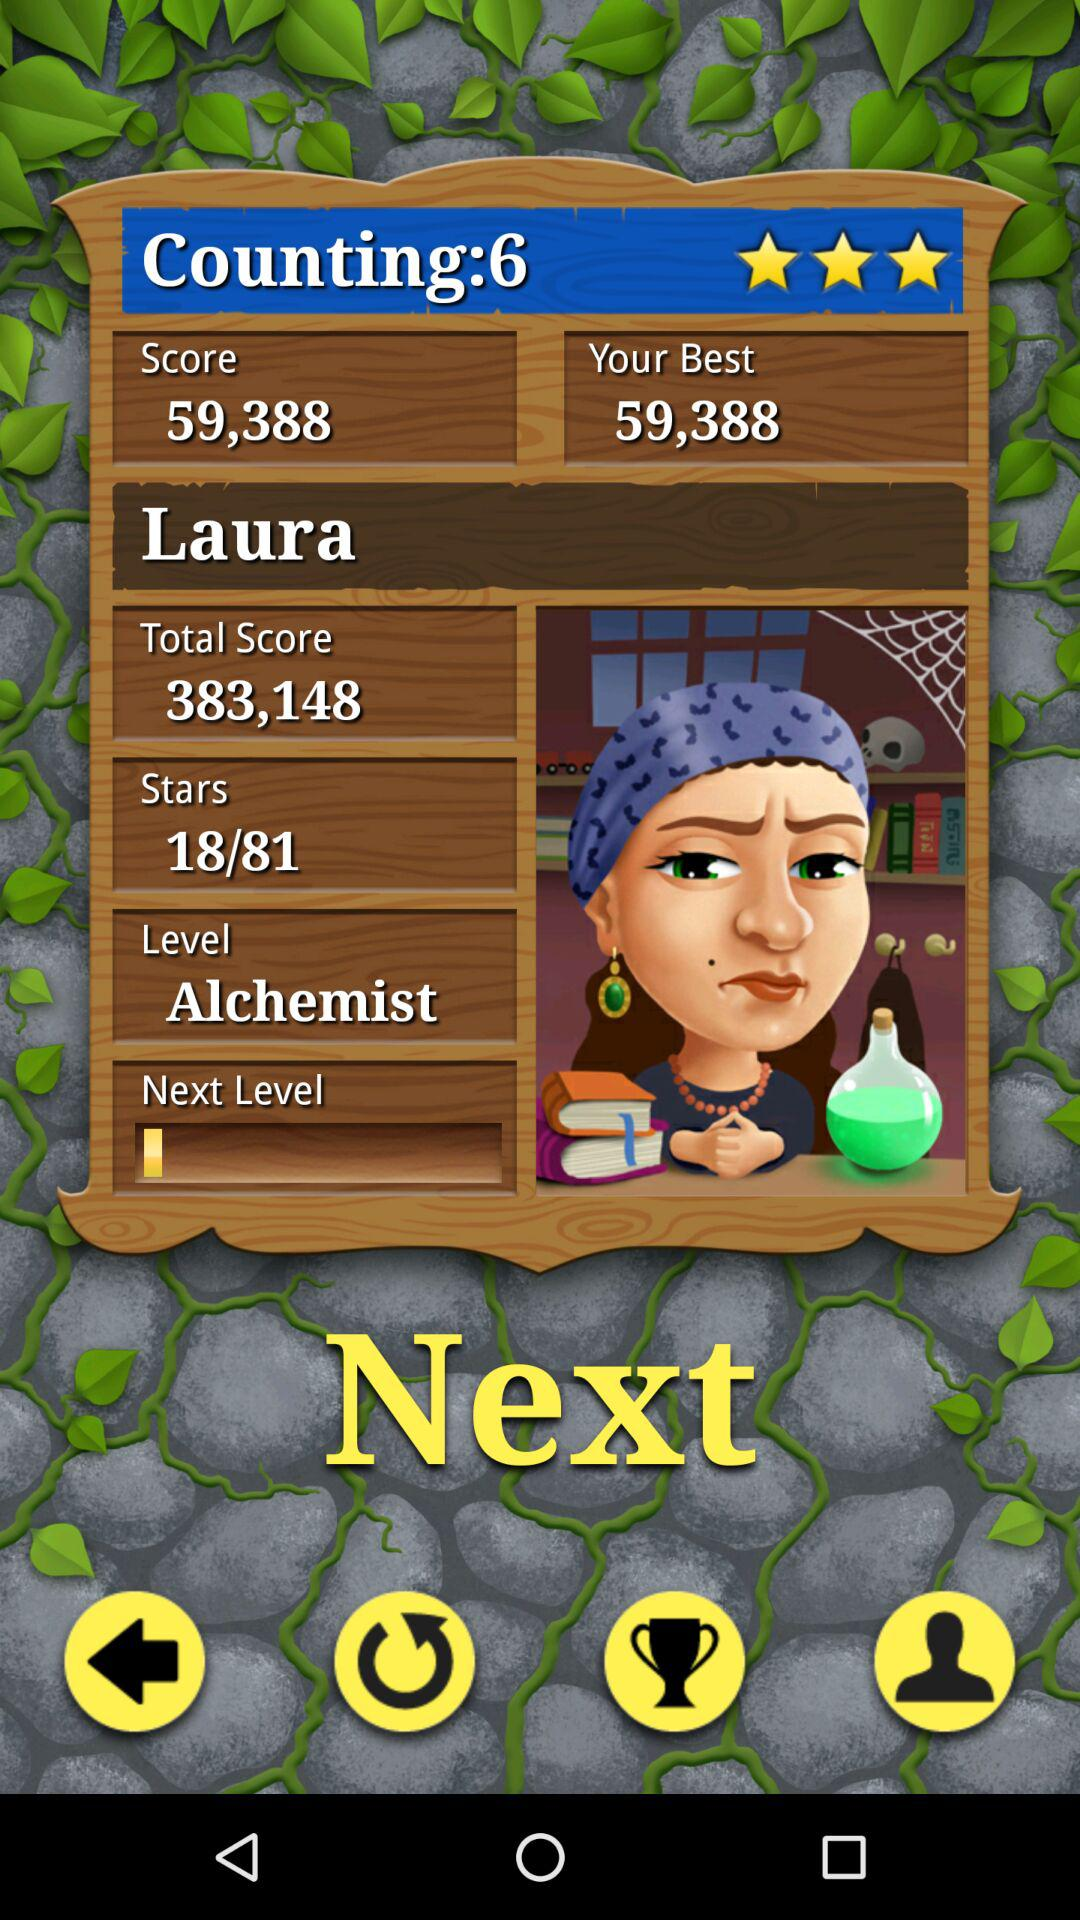What is the best score? The best score is 59,388. 